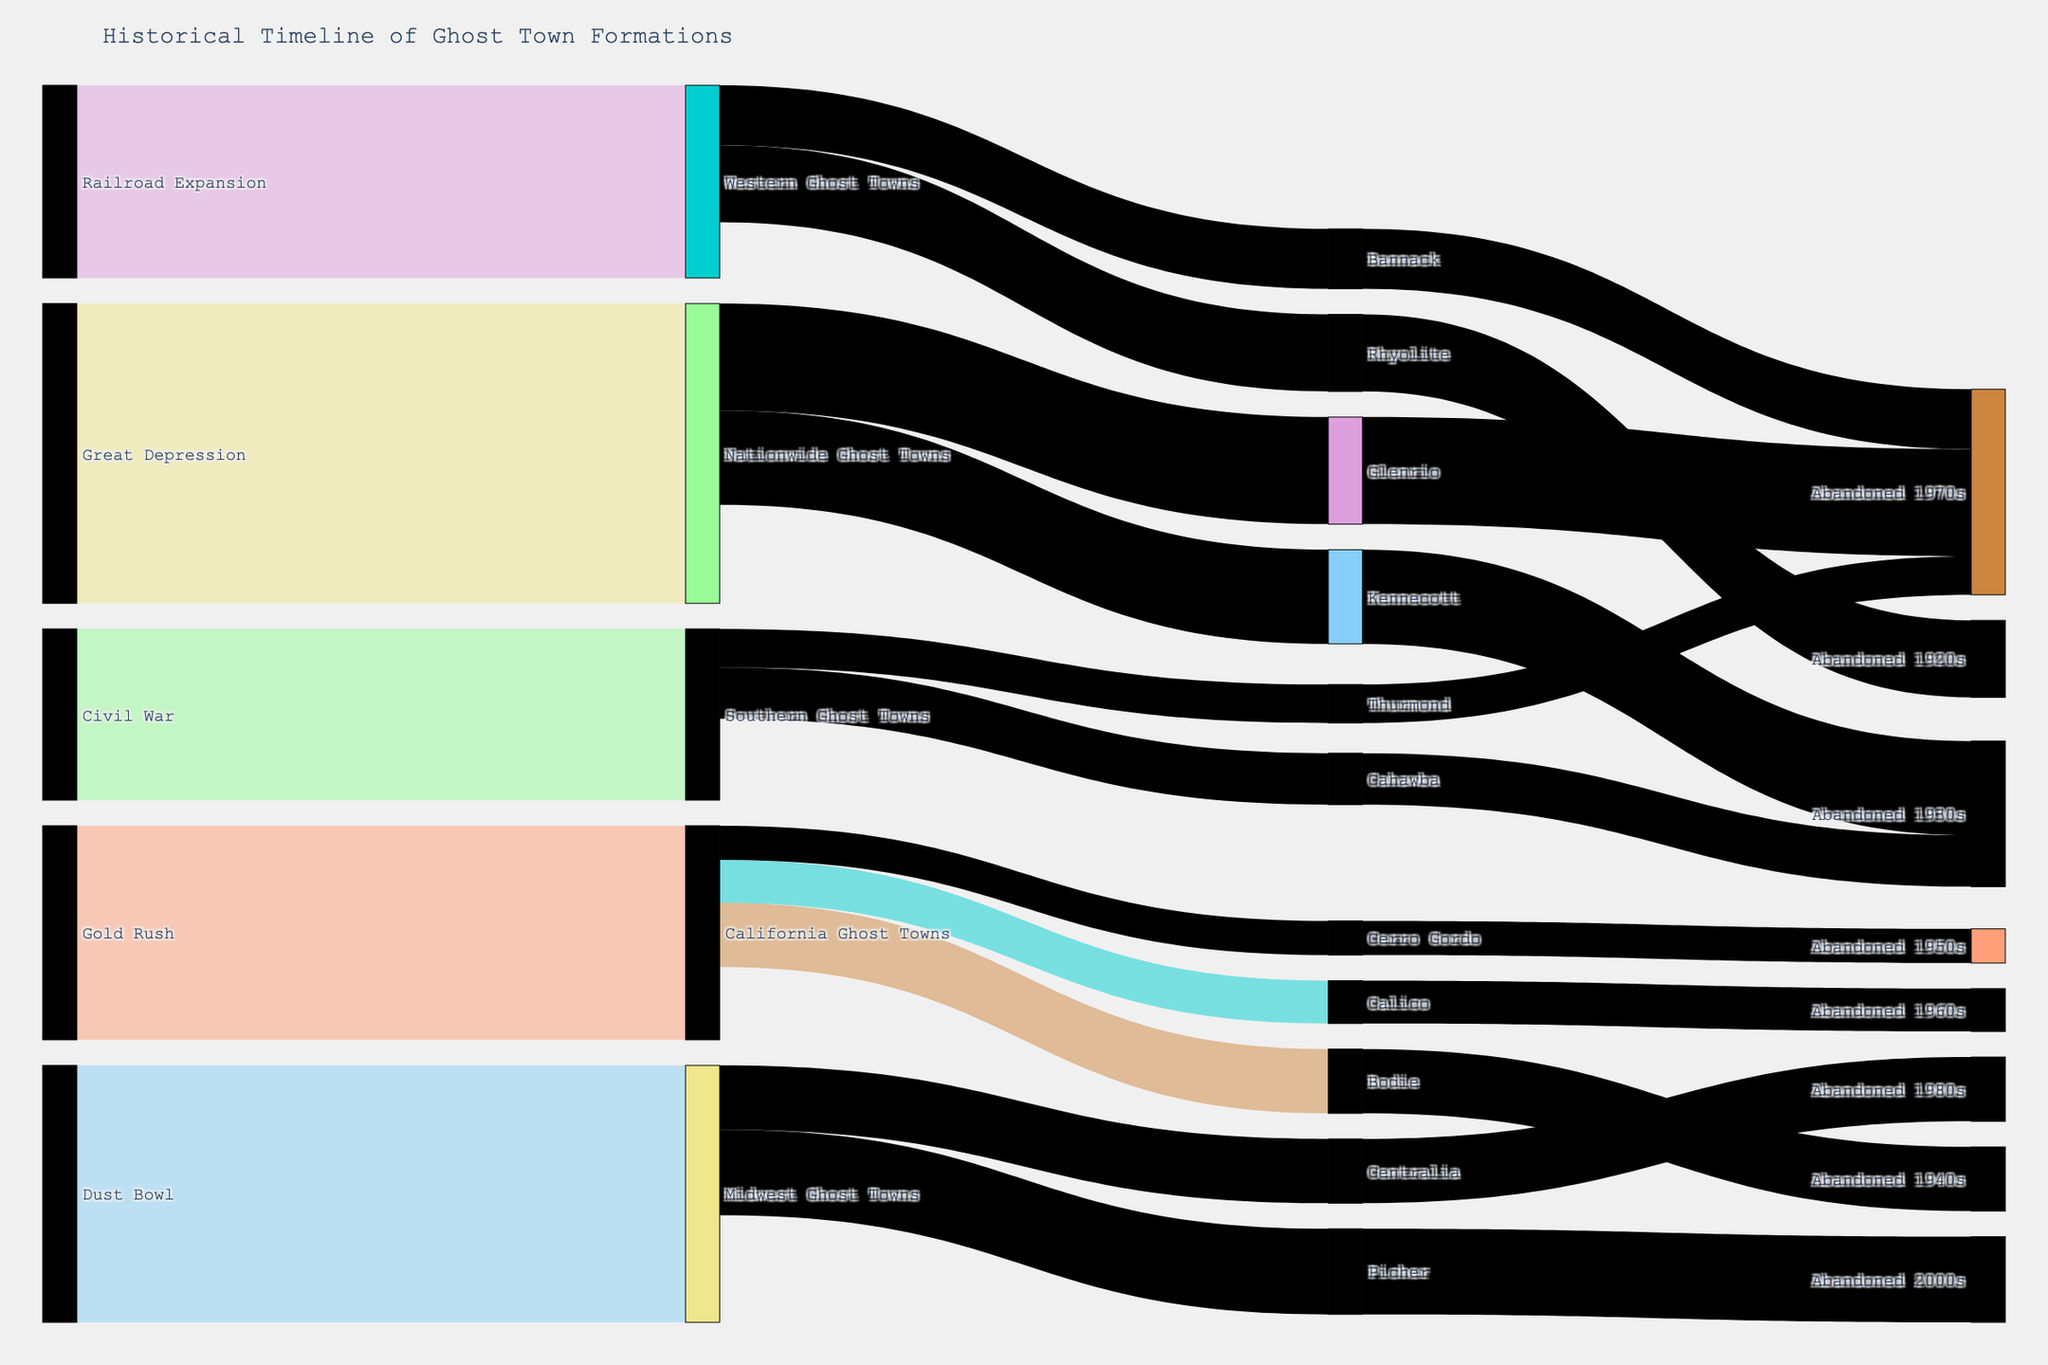What's the title of the figure? The title is prominently displayed at the top of the figure, providing an overview of the visualized data's theme.
Answer: Historical Timeline of Ghost Town Formations Which major event led to the formation of the most ghost towns? By comparing the values linked to each major event, we can see that the Great Depression has the highest value, indicating it led to the formation of the most ghost towns.
Answer: Great Depression How many ghost towns were formed due to the Gold Rush? The value in the link between the Gold Rush and California Ghost Towns shows the number of ghost towns formed.
Answer: 50 Of the California Ghost Towns listed, which one was abandoned the earliest? By tracing the sequence from California Ghost Towns to the listed towns and checking the abandonment dates, Rhyolite was abandoned in the 1920s, the earliest among them.
Answer: Rhyolite Which ghost town formation is directly linked to Midwest Ghost Towns? The links stemming from Midwest Ghost Towns will show the directly related ghost town formations.
Answer: Picher, Centralia From the Southern Ghost Towns, which had fewer ghost towns formed: Cahawba or Thurmond? By comparing the values branching from Southern Ghost Towns to Cahawba and Thurmond, Thurmond has fewer ghost towns formed with a value of 9 compared to Cahawba's 12.
Answer: Thurmond How many ghost towns were formed during the Civil War? By examining the value linked between the Civil War and Southern Ghost Towns.
Answer: 40 What is the total number of ghost towns linked to the Great Depression? By checking the values connected to the Great Depression and summing them up.
Answer: 70 Which abandoned ghost town had the latest abandonment date? By comparing the listed abandonment dates for each linked ghost town, Picher shows the latest abandonment date in the 2000s.
Answer: Picher Which ghost town listed under Western Ghost Towns has the highest abandonment value? By examining the values associated with ghost towns under Western Ghost Towns, Rhyolite has the highest value with 18.
Answer: Rhyolite 